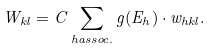<formula> <loc_0><loc_0><loc_500><loc_500>W _ { k l } = C \sum _ { h a s s o c . } g ( E _ { h } ) \cdot w _ { h k l } .</formula> 